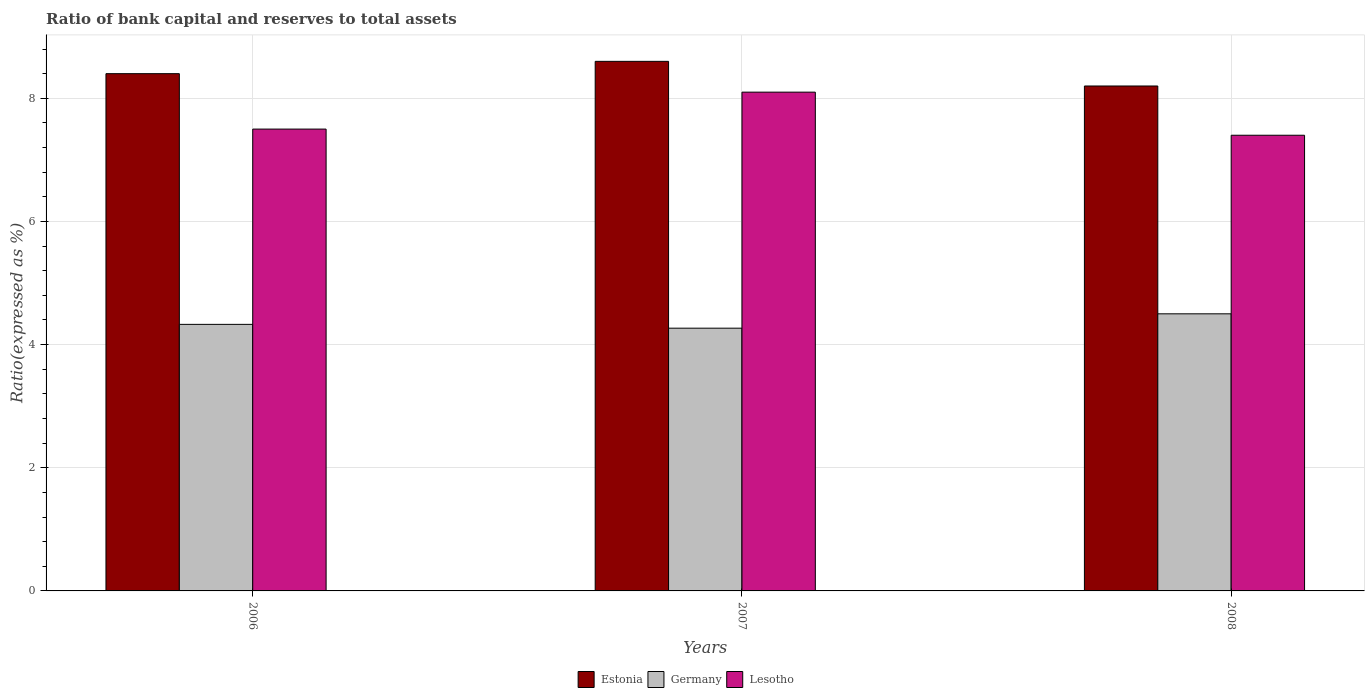How many groups of bars are there?
Provide a short and direct response. 3. Are the number of bars on each tick of the X-axis equal?
Your answer should be compact. Yes. What is the label of the 2nd group of bars from the left?
Provide a short and direct response. 2007. In how many cases, is the number of bars for a given year not equal to the number of legend labels?
Ensure brevity in your answer.  0. What is the ratio of bank capital and reserves to total assets in Germany in 2007?
Keep it short and to the point. 4.27. Across all years, what is the minimum ratio of bank capital and reserves to total assets in Lesotho?
Keep it short and to the point. 7.4. In which year was the ratio of bank capital and reserves to total assets in Germany maximum?
Provide a succinct answer. 2008. In which year was the ratio of bank capital and reserves to total assets in Germany minimum?
Ensure brevity in your answer.  2007. What is the total ratio of bank capital and reserves to total assets in Estonia in the graph?
Offer a terse response. 25.2. What is the difference between the ratio of bank capital and reserves to total assets in Lesotho in 2006 and that in 2007?
Give a very brief answer. -0.6. What is the difference between the ratio of bank capital and reserves to total assets in Germany in 2007 and the ratio of bank capital and reserves to total assets in Lesotho in 2006?
Ensure brevity in your answer.  -3.23. What is the average ratio of bank capital and reserves to total assets in Lesotho per year?
Offer a very short reply. 7.67. In the year 2007, what is the difference between the ratio of bank capital and reserves to total assets in Estonia and ratio of bank capital and reserves to total assets in Germany?
Offer a terse response. 4.33. What is the ratio of the ratio of bank capital and reserves to total assets in Lesotho in 2006 to that in 2007?
Your answer should be compact. 0.93. Is the difference between the ratio of bank capital and reserves to total assets in Estonia in 2006 and 2007 greater than the difference between the ratio of bank capital and reserves to total assets in Germany in 2006 and 2007?
Keep it short and to the point. No. What is the difference between the highest and the second highest ratio of bank capital and reserves to total assets in Lesotho?
Give a very brief answer. 0.6. What is the difference between the highest and the lowest ratio of bank capital and reserves to total assets in Germany?
Your answer should be very brief. 0.23. Is the sum of the ratio of bank capital and reserves to total assets in Germany in 2007 and 2008 greater than the maximum ratio of bank capital and reserves to total assets in Estonia across all years?
Provide a succinct answer. Yes. What does the 2nd bar from the left in 2006 represents?
Keep it short and to the point. Germany. What does the 1st bar from the right in 2008 represents?
Your response must be concise. Lesotho. Is it the case that in every year, the sum of the ratio of bank capital and reserves to total assets in Estonia and ratio of bank capital and reserves to total assets in Germany is greater than the ratio of bank capital and reserves to total assets in Lesotho?
Provide a succinct answer. Yes. How many bars are there?
Offer a terse response. 9. Are all the bars in the graph horizontal?
Give a very brief answer. No. How many years are there in the graph?
Offer a very short reply. 3. Does the graph contain any zero values?
Your answer should be very brief. No. Does the graph contain grids?
Ensure brevity in your answer.  Yes. How are the legend labels stacked?
Keep it short and to the point. Horizontal. What is the title of the graph?
Your response must be concise. Ratio of bank capital and reserves to total assets. What is the label or title of the X-axis?
Provide a succinct answer. Years. What is the label or title of the Y-axis?
Make the answer very short. Ratio(expressed as %). What is the Ratio(expressed as %) in Estonia in 2006?
Offer a very short reply. 8.4. What is the Ratio(expressed as %) in Germany in 2006?
Offer a very short reply. 4.33. What is the Ratio(expressed as %) in Germany in 2007?
Make the answer very short. 4.27. What is the Ratio(expressed as %) of Germany in 2008?
Provide a succinct answer. 4.5. Across all years, what is the maximum Ratio(expressed as %) of Estonia?
Your response must be concise. 8.6. Across all years, what is the maximum Ratio(expressed as %) in Lesotho?
Offer a terse response. 8.1. Across all years, what is the minimum Ratio(expressed as %) in Germany?
Your response must be concise. 4.27. Across all years, what is the minimum Ratio(expressed as %) of Lesotho?
Provide a succinct answer. 7.4. What is the total Ratio(expressed as %) in Estonia in the graph?
Offer a very short reply. 25.2. What is the total Ratio(expressed as %) of Germany in the graph?
Make the answer very short. 13.1. What is the difference between the Ratio(expressed as %) of Germany in 2006 and that in 2007?
Give a very brief answer. 0.06. What is the difference between the Ratio(expressed as %) of Lesotho in 2006 and that in 2007?
Your answer should be very brief. -0.6. What is the difference between the Ratio(expressed as %) of Germany in 2006 and that in 2008?
Keep it short and to the point. -0.17. What is the difference between the Ratio(expressed as %) of Germany in 2007 and that in 2008?
Your answer should be very brief. -0.23. What is the difference between the Ratio(expressed as %) of Estonia in 2006 and the Ratio(expressed as %) of Germany in 2007?
Ensure brevity in your answer.  4.13. What is the difference between the Ratio(expressed as %) of Estonia in 2006 and the Ratio(expressed as %) of Lesotho in 2007?
Keep it short and to the point. 0.3. What is the difference between the Ratio(expressed as %) in Germany in 2006 and the Ratio(expressed as %) in Lesotho in 2007?
Give a very brief answer. -3.77. What is the difference between the Ratio(expressed as %) of Estonia in 2006 and the Ratio(expressed as %) of Lesotho in 2008?
Provide a short and direct response. 1. What is the difference between the Ratio(expressed as %) of Germany in 2006 and the Ratio(expressed as %) of Lesotho in 2008?
Your answer should be compact. -3.07. What is the difference between the Ratio(expressed as %) in Estonia in 2007 and the Ratio(expressed as %) in Germany in 2008?
Keep it short and to the point. 4.1. What is the difference between the Ratio(expressed as %) in Germany in 2007 and the Ratio(expressed as %) in Lesotho in 2008?
Your response must be concise. -3.13. What is the average Ratio(expressed as %) in Estonia per year?
Provide a succinct answer. 8.4. What is the average Ratio(expressed as %) in Germany per year?
Ensure brevity in your answer.  4.37. What is the average Ratio(expressed as %) of Lesotho per year?
Give a very brief answer. 7.67. In the year 2006, what is the difference between the Ratio(expressed as %) of Estonia and Ratio(expressed as %) of Germany?
Make the answer very short. 4.07. In the year 2006, what is the difference between the Ratio(expressed as %) in Germany and Ratio(expressed as %) in Lesotho?
Provide a succinct answer. -3.17. In the year 2007, what is the difference between the Ratio(expressed as %) in Estonia and Ratio(expressed as %) in Germany?
Offer a terse response. 4.33. In the year 2007, what is the difference between the Ratio(expressed as %) in Estonia and Ratio(expressed as %) in Lesotho?
Give a very brief answer. 0.5. In the year 2007, what is the difference between the Ratio(expressed as %) of Germany and Ratio(expressed as %) of Lesotho?
Offer a very short reply. -3.83. In the year 2008, what is the difference between the Ratio(expressed as %) of Estonia and Ratio(expressed as %) of Lesotho?
Keep it short and to the point. 0.8. What is the ratio of the Ratio(expressed as %) in Estonia in 2006 to that in 2007?
Offer a very short reply. 0.98. What is the ratio of the Ratio(expressed as %) in Germany in 2006 to that in 2007?
Your response must be concise. 1.01. What is the ratio of the Ratio(expressed as %) of Lesotho in 2006 to that in 2007?
Ensure brevity in your answer.  0.93. What is the ratio of the Ratio(expressed as %) of Estonia in 2006 to that in 2008?
Your response must be concise. 1.02. What is the ratio of the Ratio(expressed as %) of Germany in 2006 to that in 2008?
Give a very brief answer. 0.96. What is the ratio of the Ratio(expressed as %) of Lesotho in 2006 to that in 2008?
Your response must be concise. 1.01. What is the ratio of the Ratio(expressed as %) of Estonia in 2007 to that in 2008?
Provide a short and direct response. 1.05. What is the ratio of the Ratio(expressed as %) in Germany in 2007 to that in 2008?
Offer a very short reply. 0.95. What is the ratio of the Ratio(expressed as %) in Lesotho in 2007 to that in 2008?
Make the answer very short. 1.09. What is the difference between the highest and the second highest Ratio(expressed as %) in Germany?
Keep it short and to the point. 0.17. What is the difference between the highest and the lowest Ratio(expressed as %) in Germany?
Give a very brief answer. 0.23. 